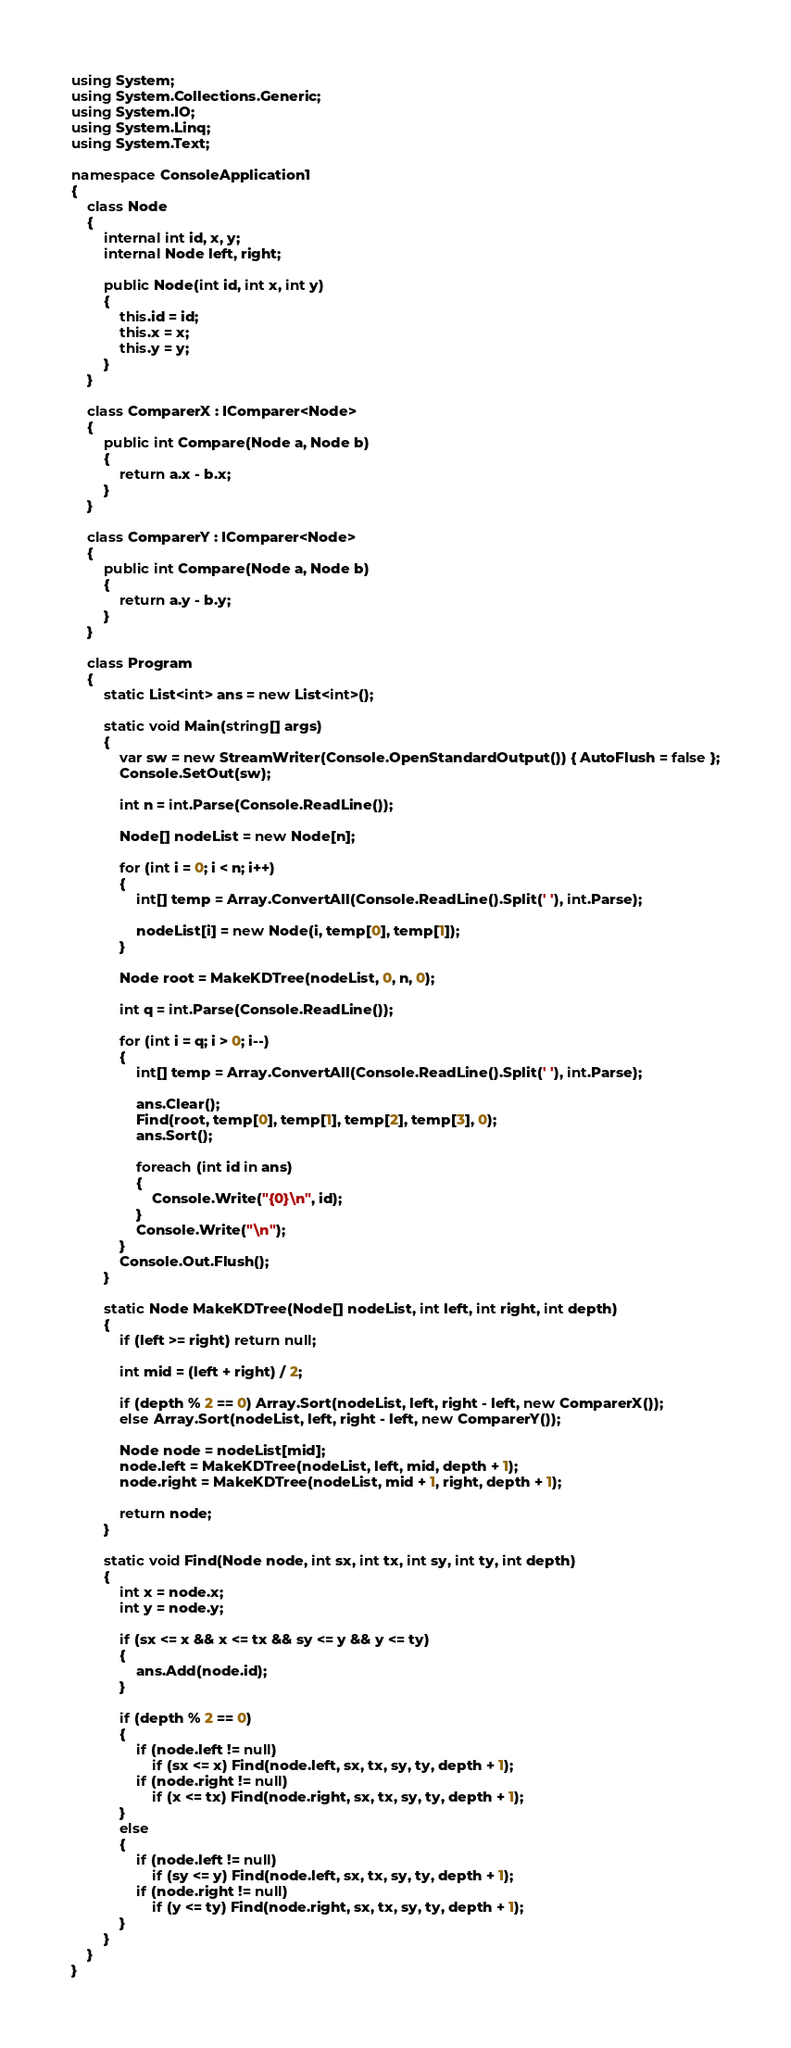Convert code to text. <code><loc_0><loc_0><loc_500><loc_500><_C#_>using System;
using System.Collections.Generic;
using System.IO;
using System.Linq;
using System.Text;

namespace ConsoleApplication1
{
    class Node
    {
        internal int id, x, y;
        internal Node left, right;

        public Node(int id, int x, int y)
        {
            this.id = id;
            this.x = x;
            this.y = y;
        }
    }

    class ComparerX : IComparer<Node>
    {
        public int Compare(Node a, Node b)
        {
            return a.x - b.x;
        }
    }

    class ComparerY : IComparer<Node>
    {
        public int Compare(Node a, Node b)
        {
            return a.y - b.y;
        }
    }

    class Program
    {
        static List<int> ans = new List<int>();

        static void Main(string[] args)
        {
            var sw = new StreamWriter(Console.OpenStandardOutput()) { AutoFlush = false };
            Console.SetOut(sw);

            int n = int.Parse(Console.ReadLine());

            Node[] nodeList = new Node[n];

            for (int i = 0; i < n; i++)
            {
                int[] temp = Array.ConvertAll(Console.ReadLine().Split(' '), int.Parse);

                nodeList[i] = new Node(i, temp[0], temp[1]);
            }

            Node root = MakeKDTree(nodeList, 0, n, 0);
            
            int q = int.Parse(Console.ReadLine());

            for (int i = q; i > 0; i--)
            {
                int[] temp = Array.ConvertAll(Console.ReadLine().Split(' '), int.Parse);

                ans.Clear();
                Find(root, temp[0], temp[1], temp[2], temp[3], 0);
                ans.Sort();

                foreach (int id in ans)
                {
                    Console.Write("{0}\n", id);
                }
                Console.Write("\n");
            }
            Console.Out.Flush();
        }

        static Node MakeKDTree(Node[] nodeList, int left, int right, int depth)
        {
            if (left >= right) return null;

            int mid = (left + right) / 2;

            if (depth % 2 == 0) Array.Sort(nodeList, left, right - left, new ComparerX());
            else Array.Sort(nodeList, left, right - left, new ComparerY());

            Node node = nodeList[mid];
            node.left = MakeKDTree(nodeList, left, mid, depth + 1);
            node.right = MakeKDTree(nodeList, mid + 1, right, depth + 1);

            return node;
        }

        static void Find(Node node, int sx, int tx, int sy, int ty, int depth)
        {
            int x = node.x;
            int y = node.y;

            if (sx <= x && x <= tx && sy <= y && y <= ty)
            {
                ans.Add(node.id);
            }

            if (depth % 2 == 0)
            {
                if (node.left != null)
                    if (sx <= x) Find(node.left, sx, tx, sy, ty, depth + 1);
                if (node.right != null)
                    if (x <= tx) Find(node.right, sx, tx, sy, ty, depth + 1);
            }
            else
            {
                if (node.left != null)
                    if (sy <= y) Find(node.left, sx, tx, sy, ty, depth + 1);
                if (node.right != null)
                    if (y <= ty) Find(node.right, sx, tx, sy, ty, depth + 1);
            }
        }
    }
}</code> 